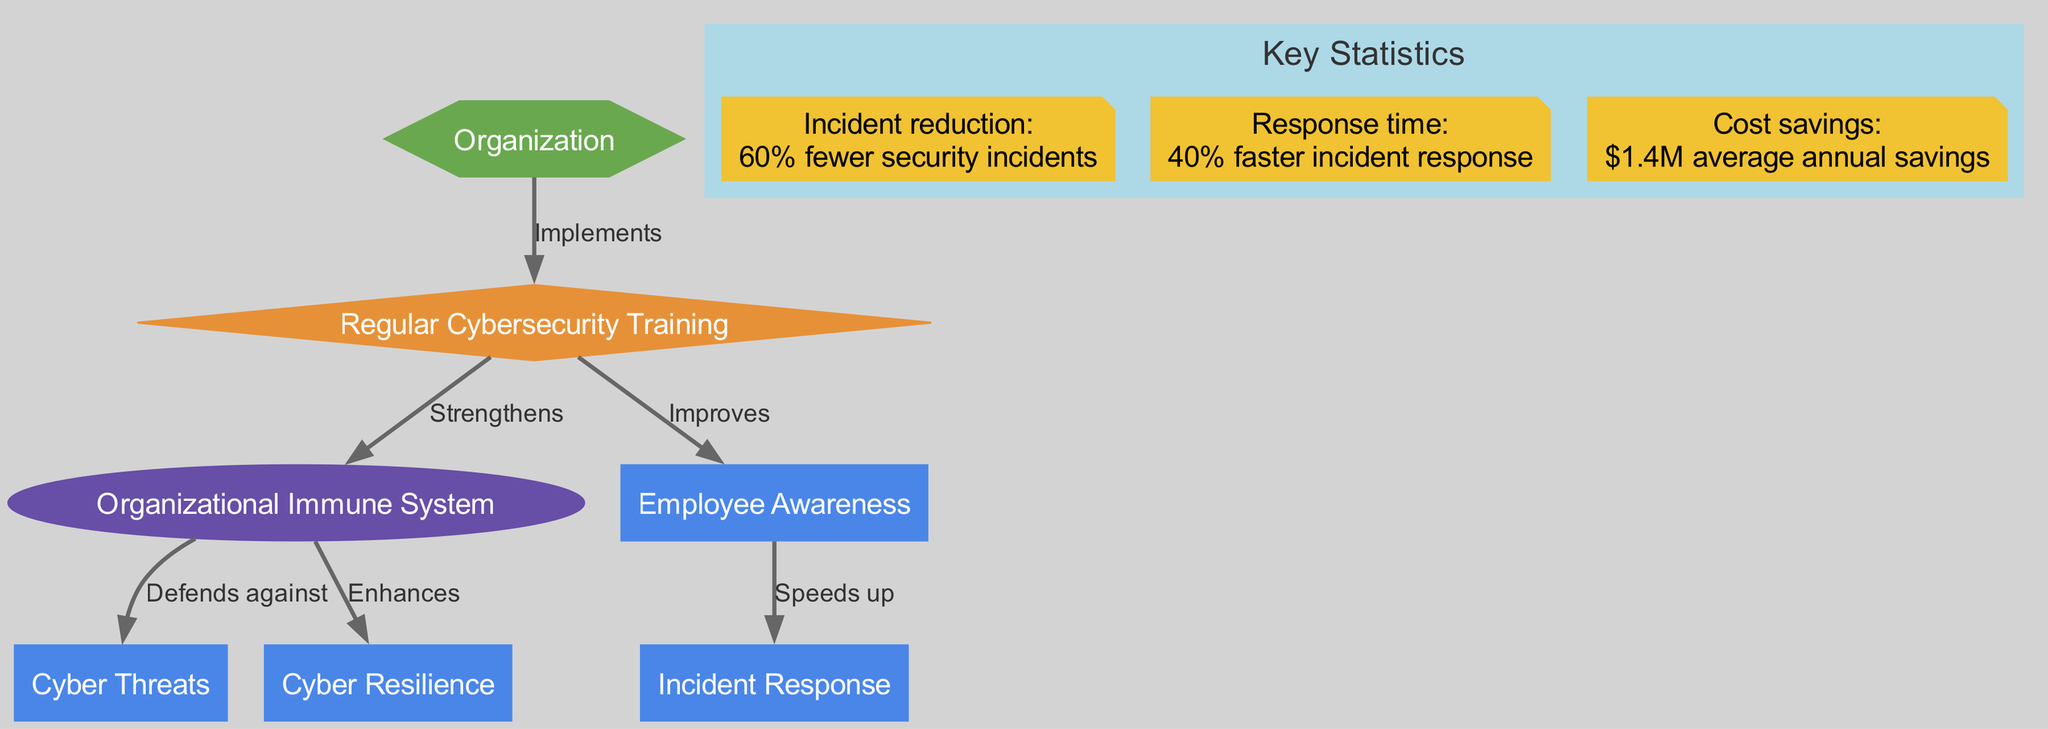What is the label of the first node in the diagram? The first node listed in the data has an ID of "organization," and its label is "Organization."
Answer: Organization How many nodes are present in the diagram? The diagram contains a total of 7 nodes as listed in the provided data under the "nodes" key.
Answer: 7 What edge connects "Regular Cybersecurity Training" to "Organizational Immune System"? The edge that connects these two nodes is labeled "Strengthens," indicating a positive influence of training on the immune system.
Answer: Strengthens What is the outcome of "Regular Cybersecurity Training" on "Employee Awareness"? According to the diagram, "Regular Cybersecurity Training" improves "Employee Awareness," signifying a beneficial effect on employee training.
Answer: Improves What percentage reduction in security incidents is highlighted in the statistics? The statistics indicate a 60% fewer security incidents, showcasing the effectiveness of training.
Answer: 60% Explain how "Organizational Immune System" enhances "Cyber Resilience." The diagram states that the "Organizational Immune System" enhances "Cyber Resilience," which means that a stronger immune system leads to better preparedness against cyber threats. This connection indicates that training impacts resilience positively.
Answer: Enhances What effect does "Employee Awareness" have on "Incident Response"? The diagram indicates that "Employee Awareness" speeds up the "Incident Response," demonstrating how awareness can lead to quicker reactions to cybersecurity incidents.
Answer: Speeds up Which node is shaped like a diamond in the diagram? The only node shaped like a diamond is "Regular Cybersecurity Training," which suggests its crucial role within the organization.
Answer: Regular Cybersecurity Training What are the statistics related to cost savings from the diagram? The statistics show that there are "$1.4M average annual savings," indicating a financial benefit of implementing cybersecurity training programs.
Answer: $1.4M average annual savings 